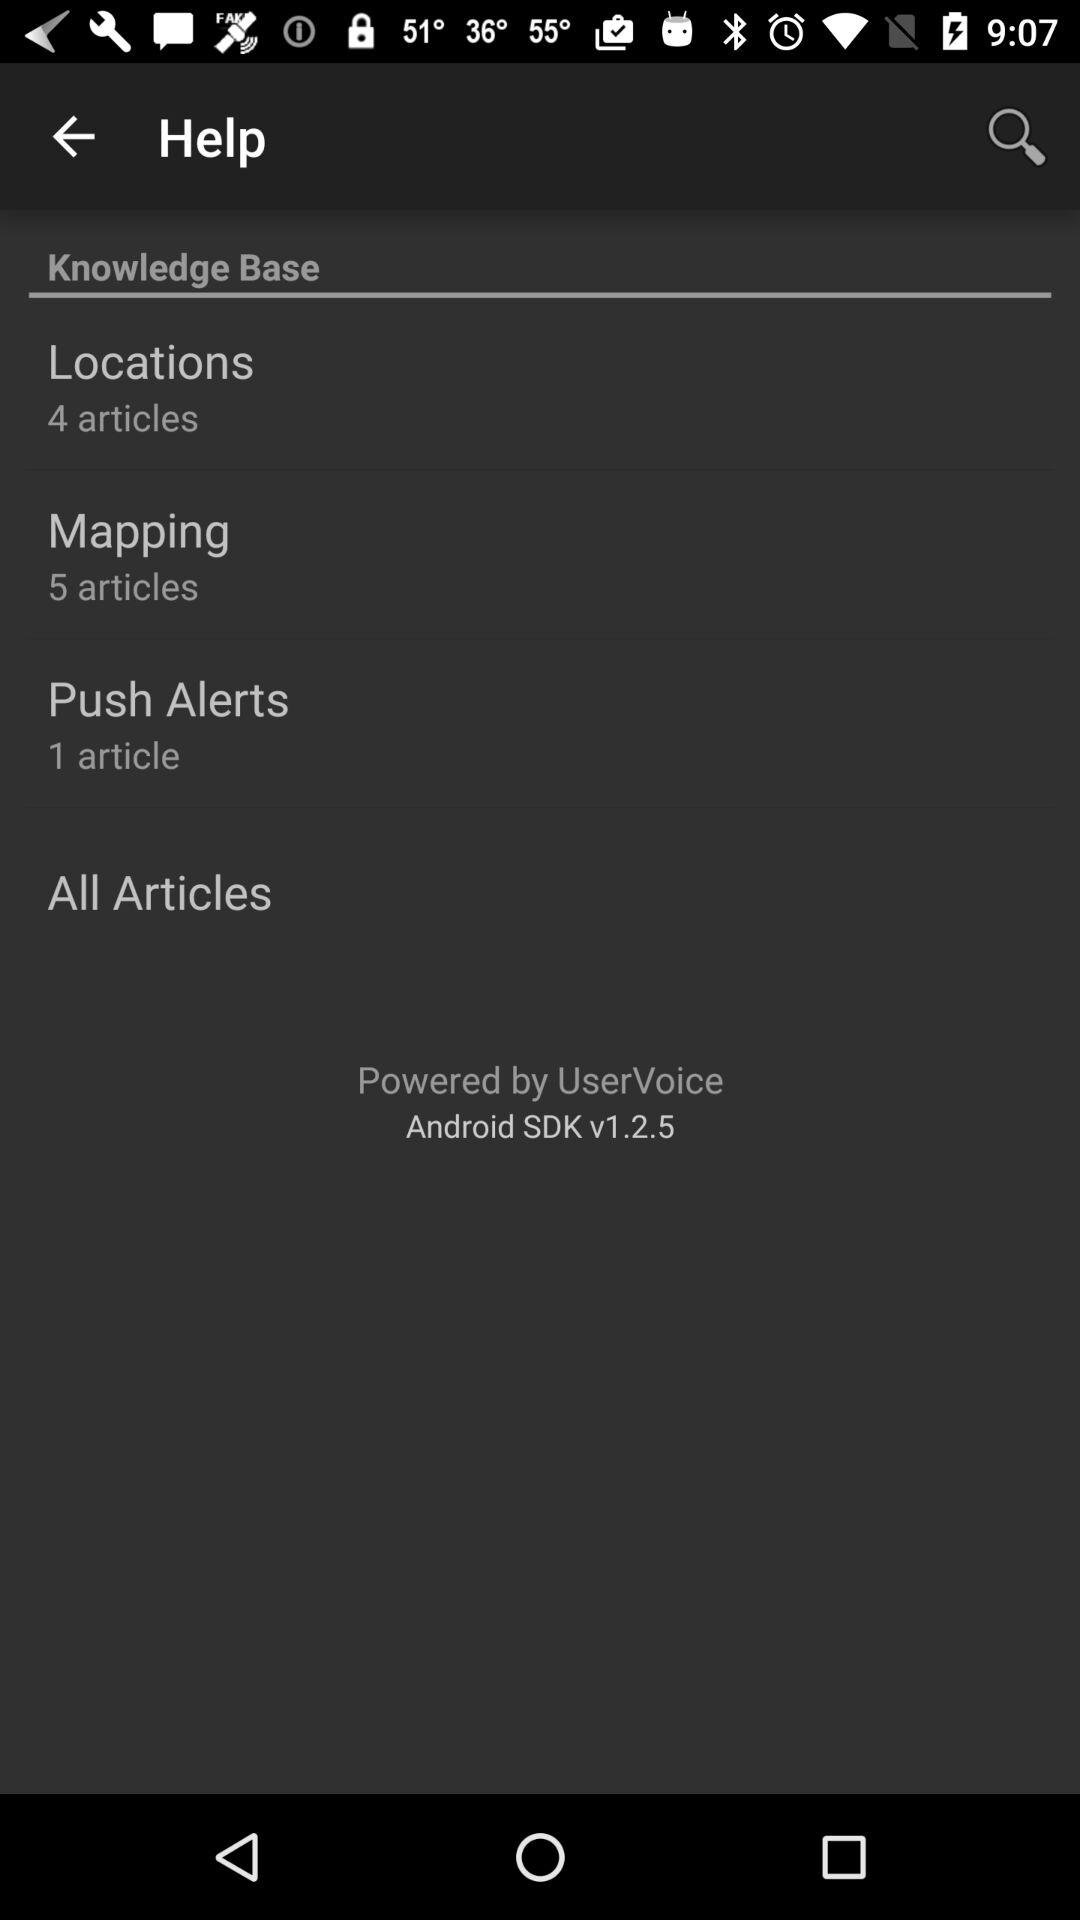How many articles are there in "Locations"? There are 4 articles in "Locations". 